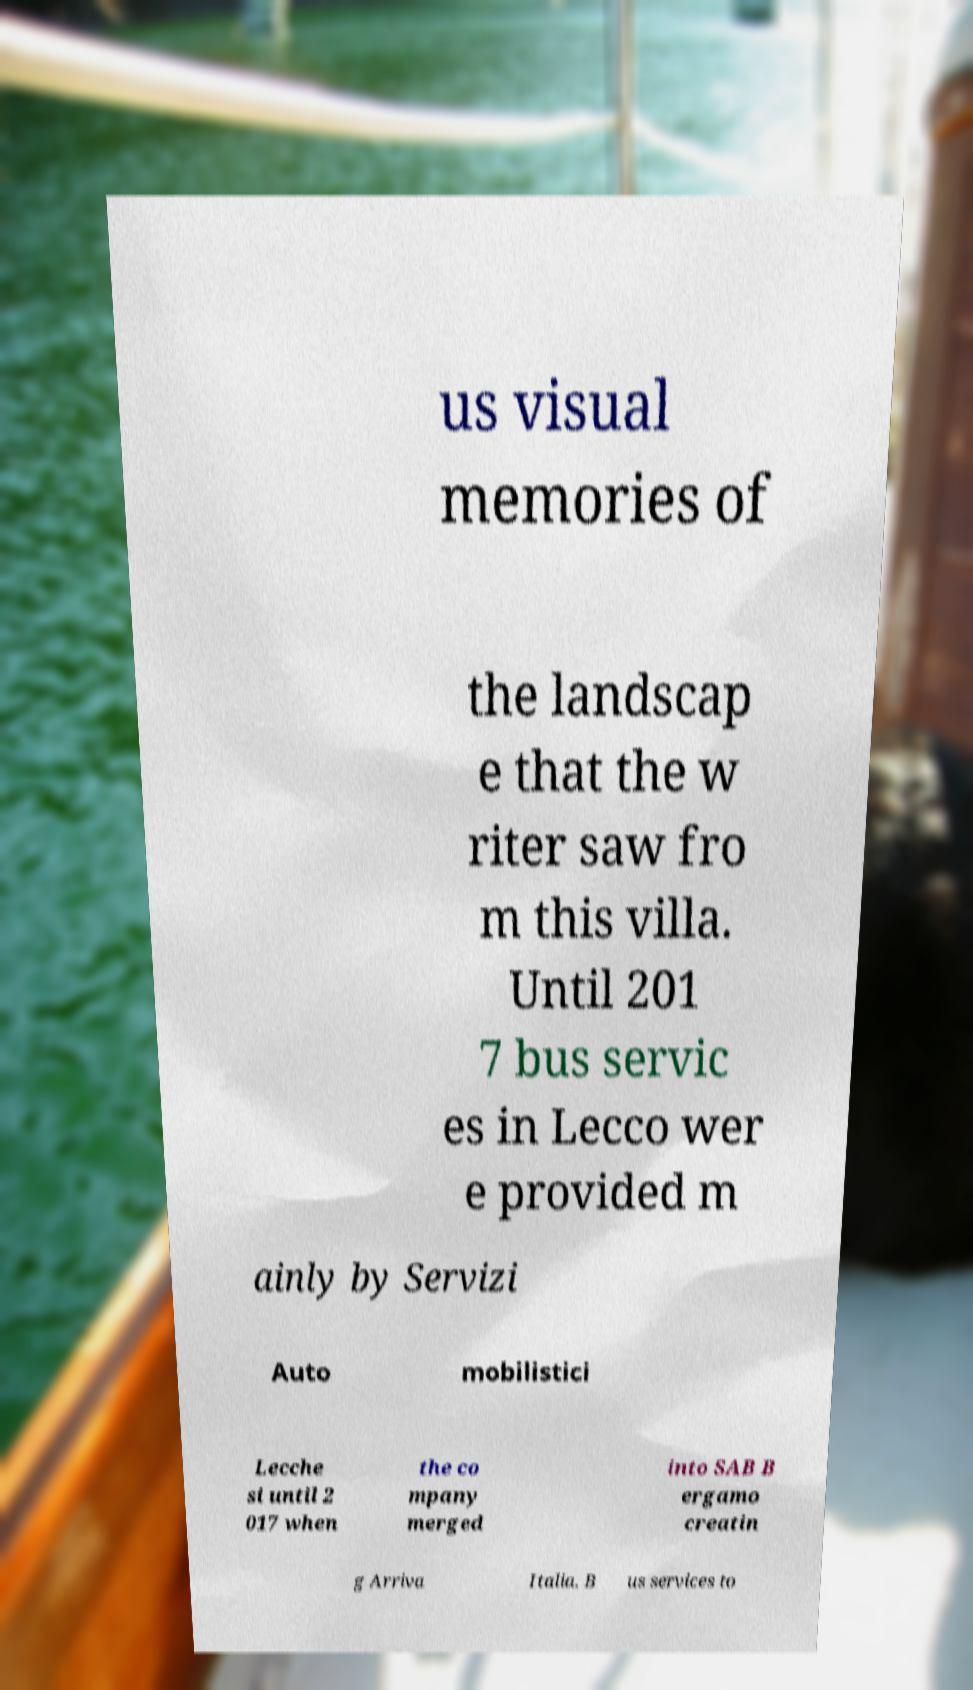Can you accurately transcribe the text from the provided image for me? us visual memories of the landscap e that the w riter saw fro m this villa. Until 201 7 bus servic es in Lecco wer e provided m ainly by Servizi Auto mobilistici Lecche si until 2 017 when the co mpany merged into SAB B ergamo creatin g Arriva Italia. B us services to 